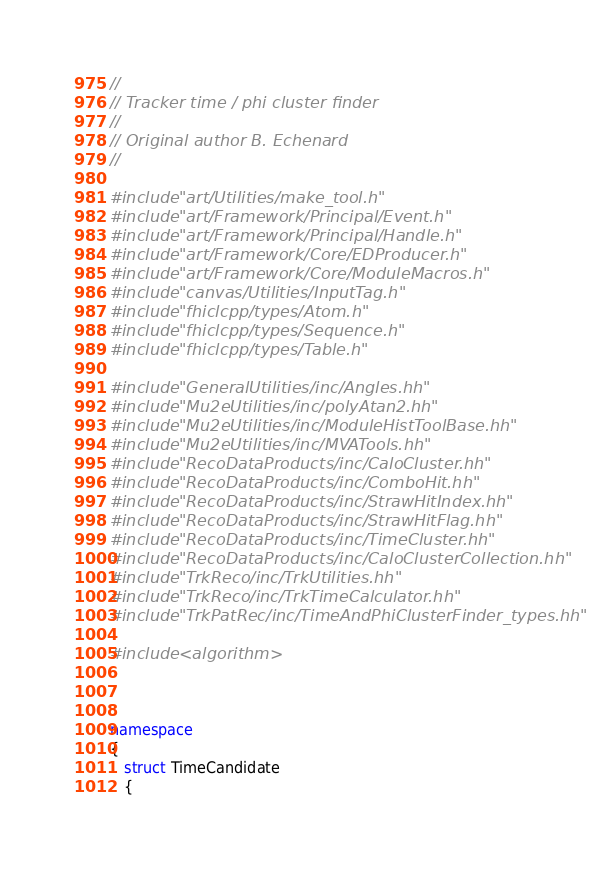<code> <loc_0><loc_0><loc_500><loc_500><_C++_>//
// Tracker time / phi cluster finder
//
// Original author B. Echenard
//

#include "art/Utilities/make_tool.h"
#include "art/Framework/Principal/Event.h"
#include "art/Framework/Principal/Handle.h"
#include "art/Framework/Core/EDProducer.h"
#include "art/Framework/Core/ModuleMacros.h"
#include "canvas/Utilities/InputTag.h"
#include "fhiclcpp/types/Atom.h"
#include "fhiclcpp/types/Sequence.h"
#include "fhiclcpp/types/Table.h"

#include "GeneralUtilities/inc/Angles.hh"
#include "Mu2eUtilities/inc/polyAtan2.hh"
#include "Mu2eUtilities/inc/ModuleHistToolBase.hh"
#include "Mu2eUtilities/inc/MVATools.hh"
#include "RecoDataProducts/inc/CaloCluster.hh"
#include "RecoDataProducts/inc/ComboHit.hh"
#include "RecoDataProducts/inc/StrawHitIndex.hh"
#include "RecoDataProducts/inc/StrawHitFlag.hh"
#include "RecoDataProducts/inc/TimeCluster.hh"
#include "RecoDataProducts/inc/CaloClusterCollection.hh"
#include "TrkReco/inc/TrkUtilities.hh"
#include "TrkReco/inc/TrkTimeCalculator.hh"
#include "TrkPatRec/inc/TimeAndPhiClusterFinder_types.hh"

#include <algorithm>



namespace
{ 
   struct TimeCandidate
   {</code> 